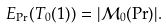Convert formula to latex. <formula><loc_0><loc_0><loc_500><loc_500>E _ { \Pr } ( T _ { 0 } ( 1 ) ) = | \mathcal { M } _ { 0 } ( \Pr ) | .</formula> 